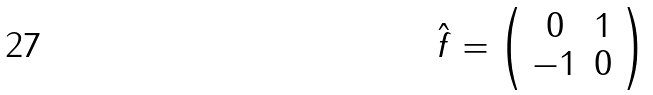<formula> <loc_0><loc_0><loc_500><loc_500>\hat { f } = \left ( \begin{array} { c c } 0 & 1 \\ - 1 & 0 \end{array} \right )</formula> 